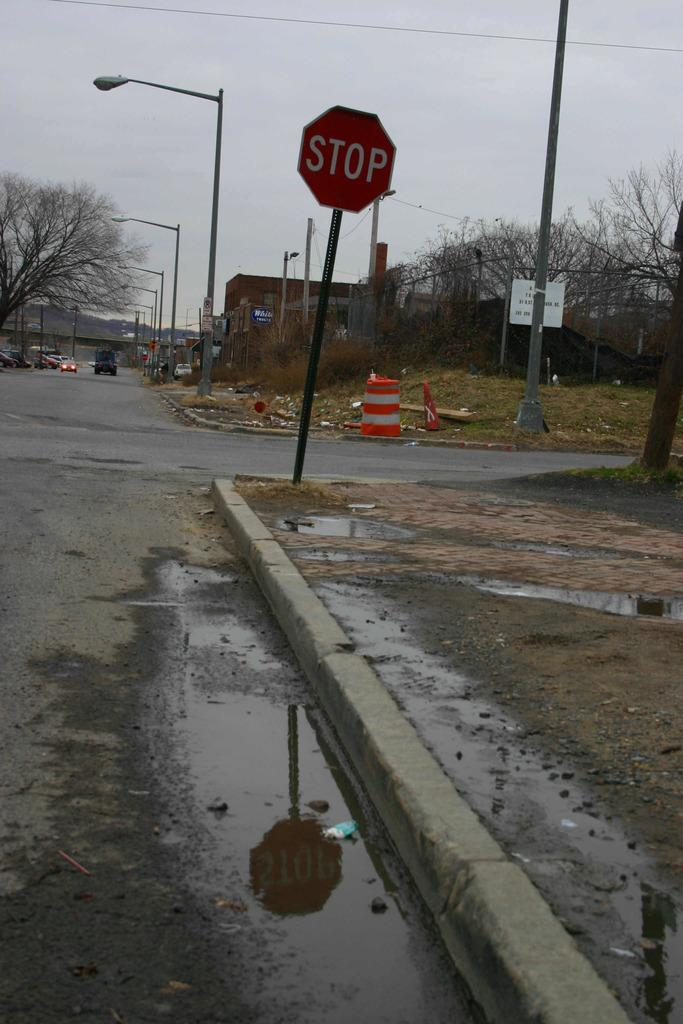<image>
Provide a brief description of the given image. a bent STOP sign on a dirty urban street 